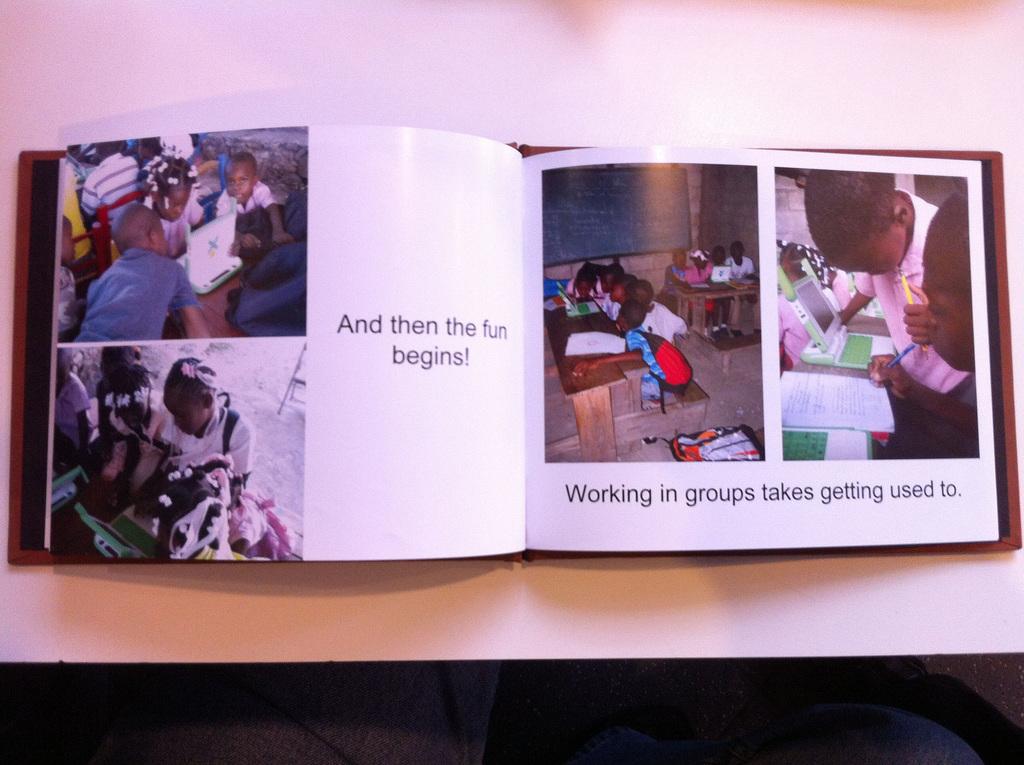What has begun?
Your answer should be compact. Fun. What are the children working in, on the right page?
Your response must be concise. Groups. 